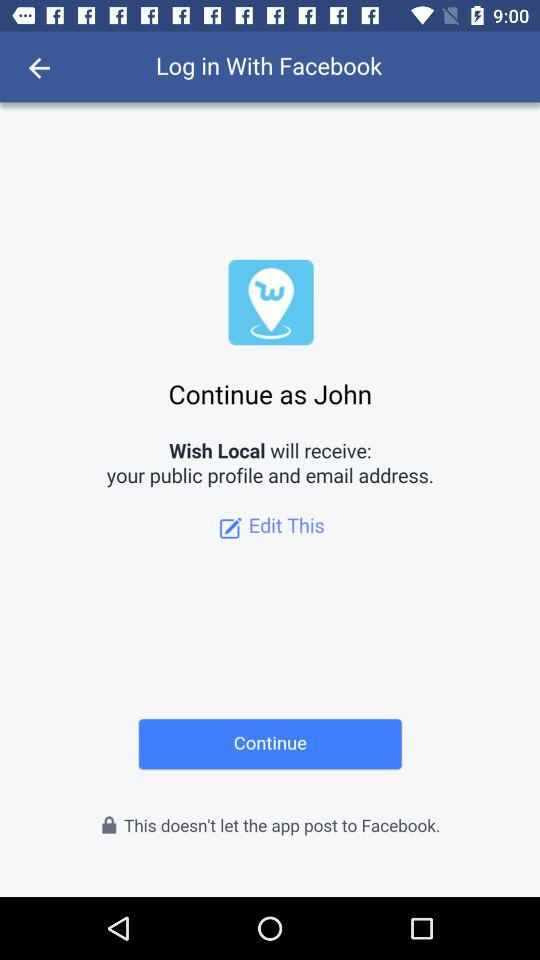What application will receive the public profile and email address? The public profile and email address will be received by "Wish Local". 